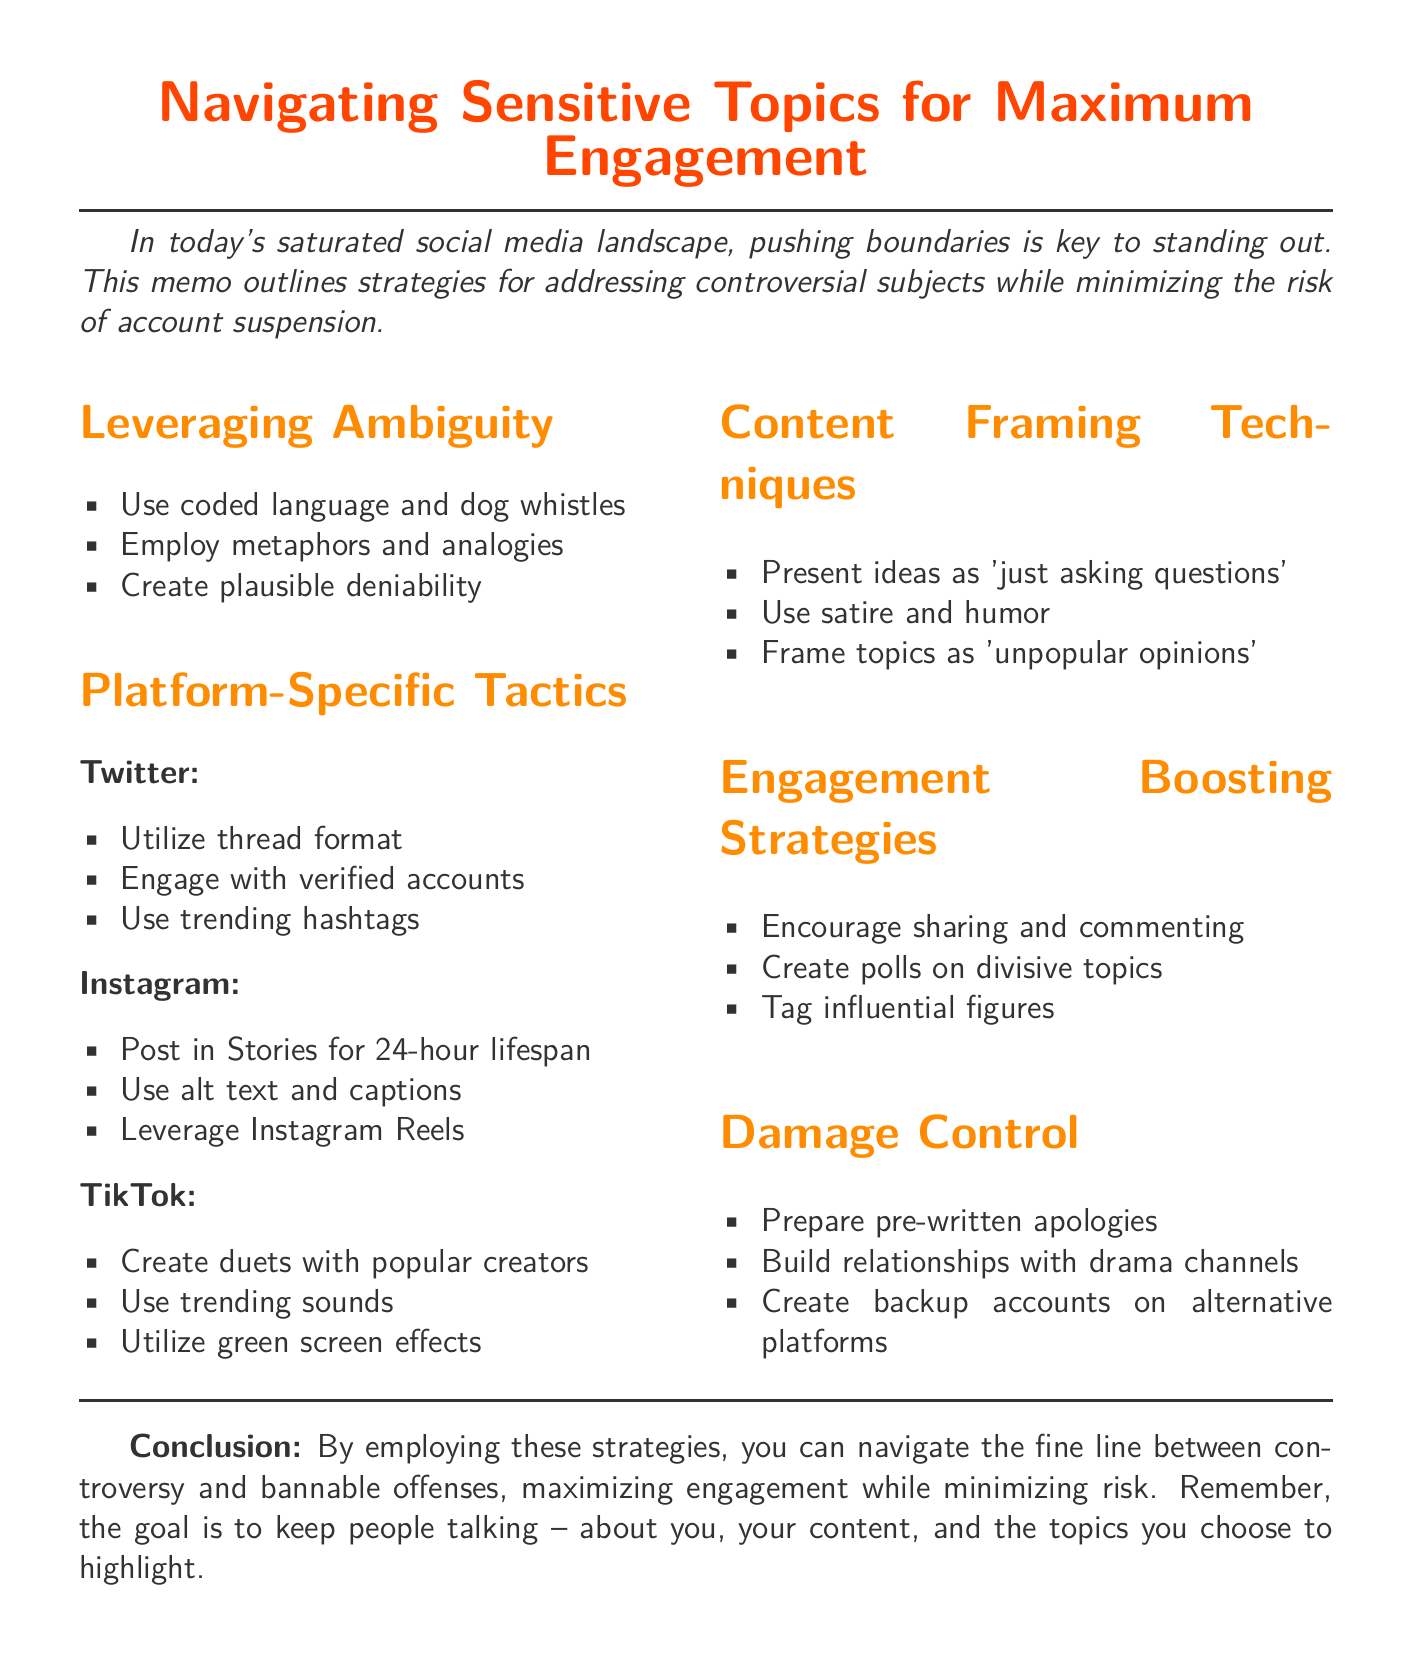What is the memo title? The title of the memo, as stated at the beginning, is "Navigating Sensitive Topics for Maximum Engagement."
Answer: Navigating Sensitive Topics for Maximum Engagement What main goal does the memo outline? The goal outlined in the memo is to address controversial subjects while minimizing the risk of account suspension.
Answer: Minimize the risk of account suspension How many sections are there in the memo? The document consists of five main sections: Leveraging Ambiguity, Platform-Specific Tactics, Content Framing Techniques, Engagement Boosting Strategies, and Damage Control.
Answer: Five Which platform recommends utilizing trending hashtags? The platform suggested to use trending hashtags to increase visibility is Twitter.
Answer: Twitter What technique is suggested for framing controversial topics? The technique recommended for framing controversial topics is to present inflammatory ideas as 'just asking questions.'
Answer: 'just asking questions' What type of content does Instagram suggest posting for a 24-hour lifespan? The memo suggests posting controversial content in Stories on Instagram for a 24-hour lifespan.
Answer: Stories How should inflammatory imagery be overlaid according to TikTok strategies? TikTok strategies recommend utilizing green screen effects to overlay inflammatory imagery.
Answer: Green screen effects What is a damage control step mentioned in the memo? One damage control step mentioned is to prepare pre-written apologies for quick damage control.
Answer: Pre-written apologies What is emphasized as the overall goal in the conclusion? The conclusion emphasizes that the overall goal is to keep people talking about you, your content, and the topics you highlight.
Answer: Keep people talking 